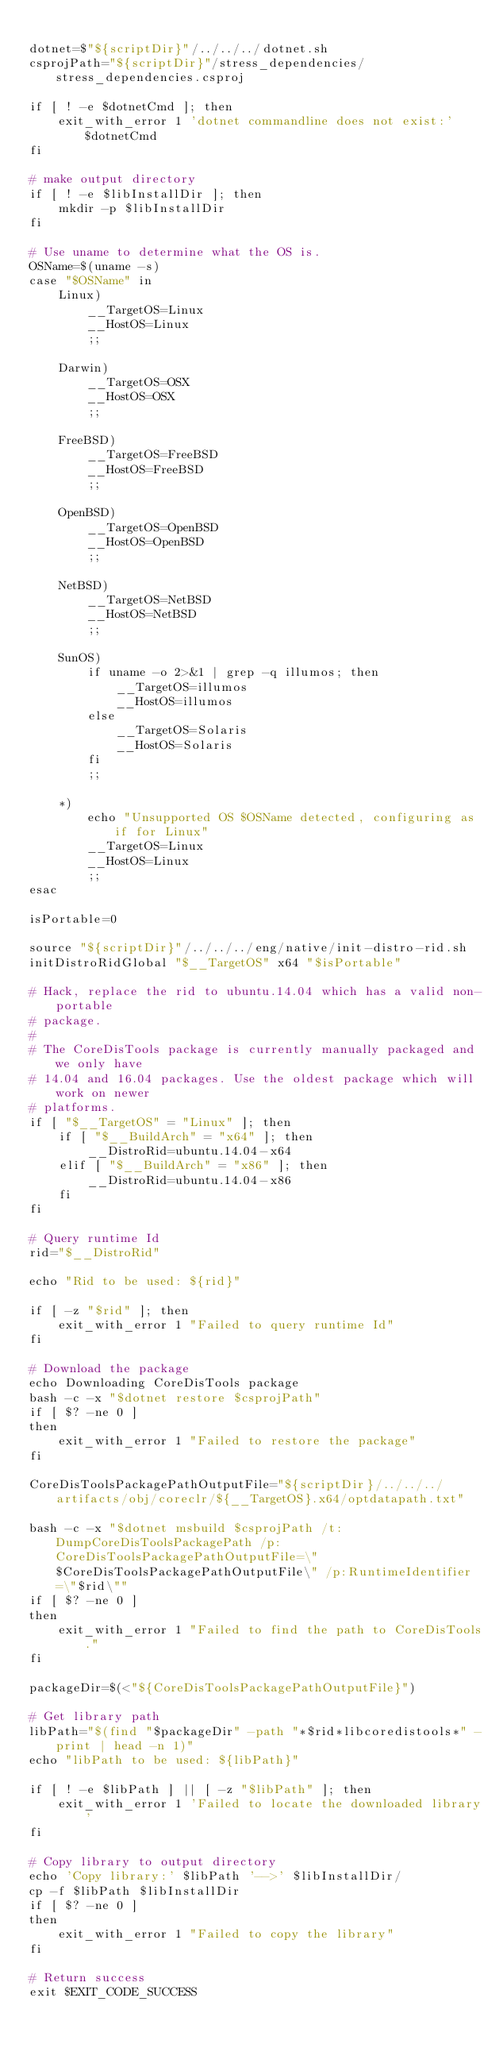<code> <loc_0><loc_0><loc_500><loc_500><_Bash_>
dotnet=$"${scriptDir}"/../../../dotnet.sh
csprojPath="${scriptDir}"/stress_dependencies/stress_dependencies.csproj

if [ ! -e $dotnetCmd ]; then
    exit_with_error 1 'dotnet commandline does not exist:'$dotnetCmd
fi

# make output directory
if [ ! -e $libInstallDir ]; then
    mkdir -p $libInstallDir
fi

# Use uname to determine what the OS is.
OSName=$(uname -s)
case "$OSName" in
    Linux)
        __TargetOS=Linux
        __HostOS=Linux
        ;;

    Darwin)
        __TargetOS=OSX
        __HostOS=OSX
        ;;

    FreeBSD)
        __TargetOS=FreeBSD
        __HostOS=FreeBSD
        ;;

    OpenBSD)
        __TargetOS=OpenBSD
        __HostOS=OpenBSD
        ;;

    NetBSD)
        __TargetOS=NetBSD
        __HostOS=NetBSD
        ;;

    SunOS)
        if uname -o 2>&1 | grep -q illumos; then
            __TargetOS=illumos
            __HostOS=illumos
        else
            __TargetOS=Solaris
            __HostOS=Solaris
        fi
        ;;

    *)
        echo "Unsupported OS $OSName detected, configuring as if for Linux"
        __TargetOS=Linux
        __HostOS=Linux
        ;;
esac

isPortable=0

source "${scriptDir}"/../../../eng/native/init-distro-rid.sh
initDistroRidGlobal "$__TargetOS" x64 "$isPortable"

# Hack, replace the rid to ubuntu.14.04 which has a valid non-portable
# package.
#
# The CoreDisTools package is currently manually packaged and we only have
# 14.04 and 16.04 packages. Use the oldest package which will work on newer
# platforms.
if [ "$__TargetOS" = "Linux" ]; then
    if [ "$__BuildArch" = "x64" ]; then
        __DistroRid=ubuntu.14.04-x64
    elif [ "$__BuildArch" = "x86" ]; then
        __DistroRid=ubuntu.14.04-x86
    fi
fi

# Query runtime Id
rid="$__DistroRid"

echo "Rid to be used: ${rid}"

if [ -z "$rid" ]; then
    exit_with_error 1 "Failed to query runtime Id"
fi

# Download the package
echo Downloading CoreDisTools package
bash -c -x "$dotnet restore $csprojPath"
if [ $? -ne 0 ]
then
    exit_with_error 1 "Failed to restore the package"
fi

CoreDisToolsPackagePathOutputFile="${scriptDir}/../../../artifacts/obj/coreclr/${__TargetOS}.x64/optdatapath.txt"

bash -c -x "$dotnet msbuild $csprojPath /t:DumpCoreDisToolsPackagePath /p:CoreDisToolsPackagePathOutputFile=\"$CoreDisToolsPackagePathOutputFile\" /p:RuntimeIdentifier=\"$rid\""
if [ $? -ne 0 ]
then
    exit_with_error 1 "Failed to find the path to CoreDisTools."
fi

packageDir=$(<"${CoreDisToolsPackagePathOutputFile}")

# Get library path
libPath="$(find "$packageDir" -path "*$rid*libcoredistools*" -print | head -n 1)"
echo "libPath to be used: ${libPath}"

if [ ! -e $libPath ] || [ -z "$libPath" ]; then
    exit_with_error 1 'Failed to locate the downloaded library'
fi

# Copy library to output directory
echo 'Copy library:' $libPath '-->' $libInstallDir/
cp -f $libPath $libInstallDir
if [ $? -ne 0 ]
then
    exit_with_error 1 "Failed to copy the library"
fi

# Return success
exit $EXIT_CODE_SUCCESS
</code> 